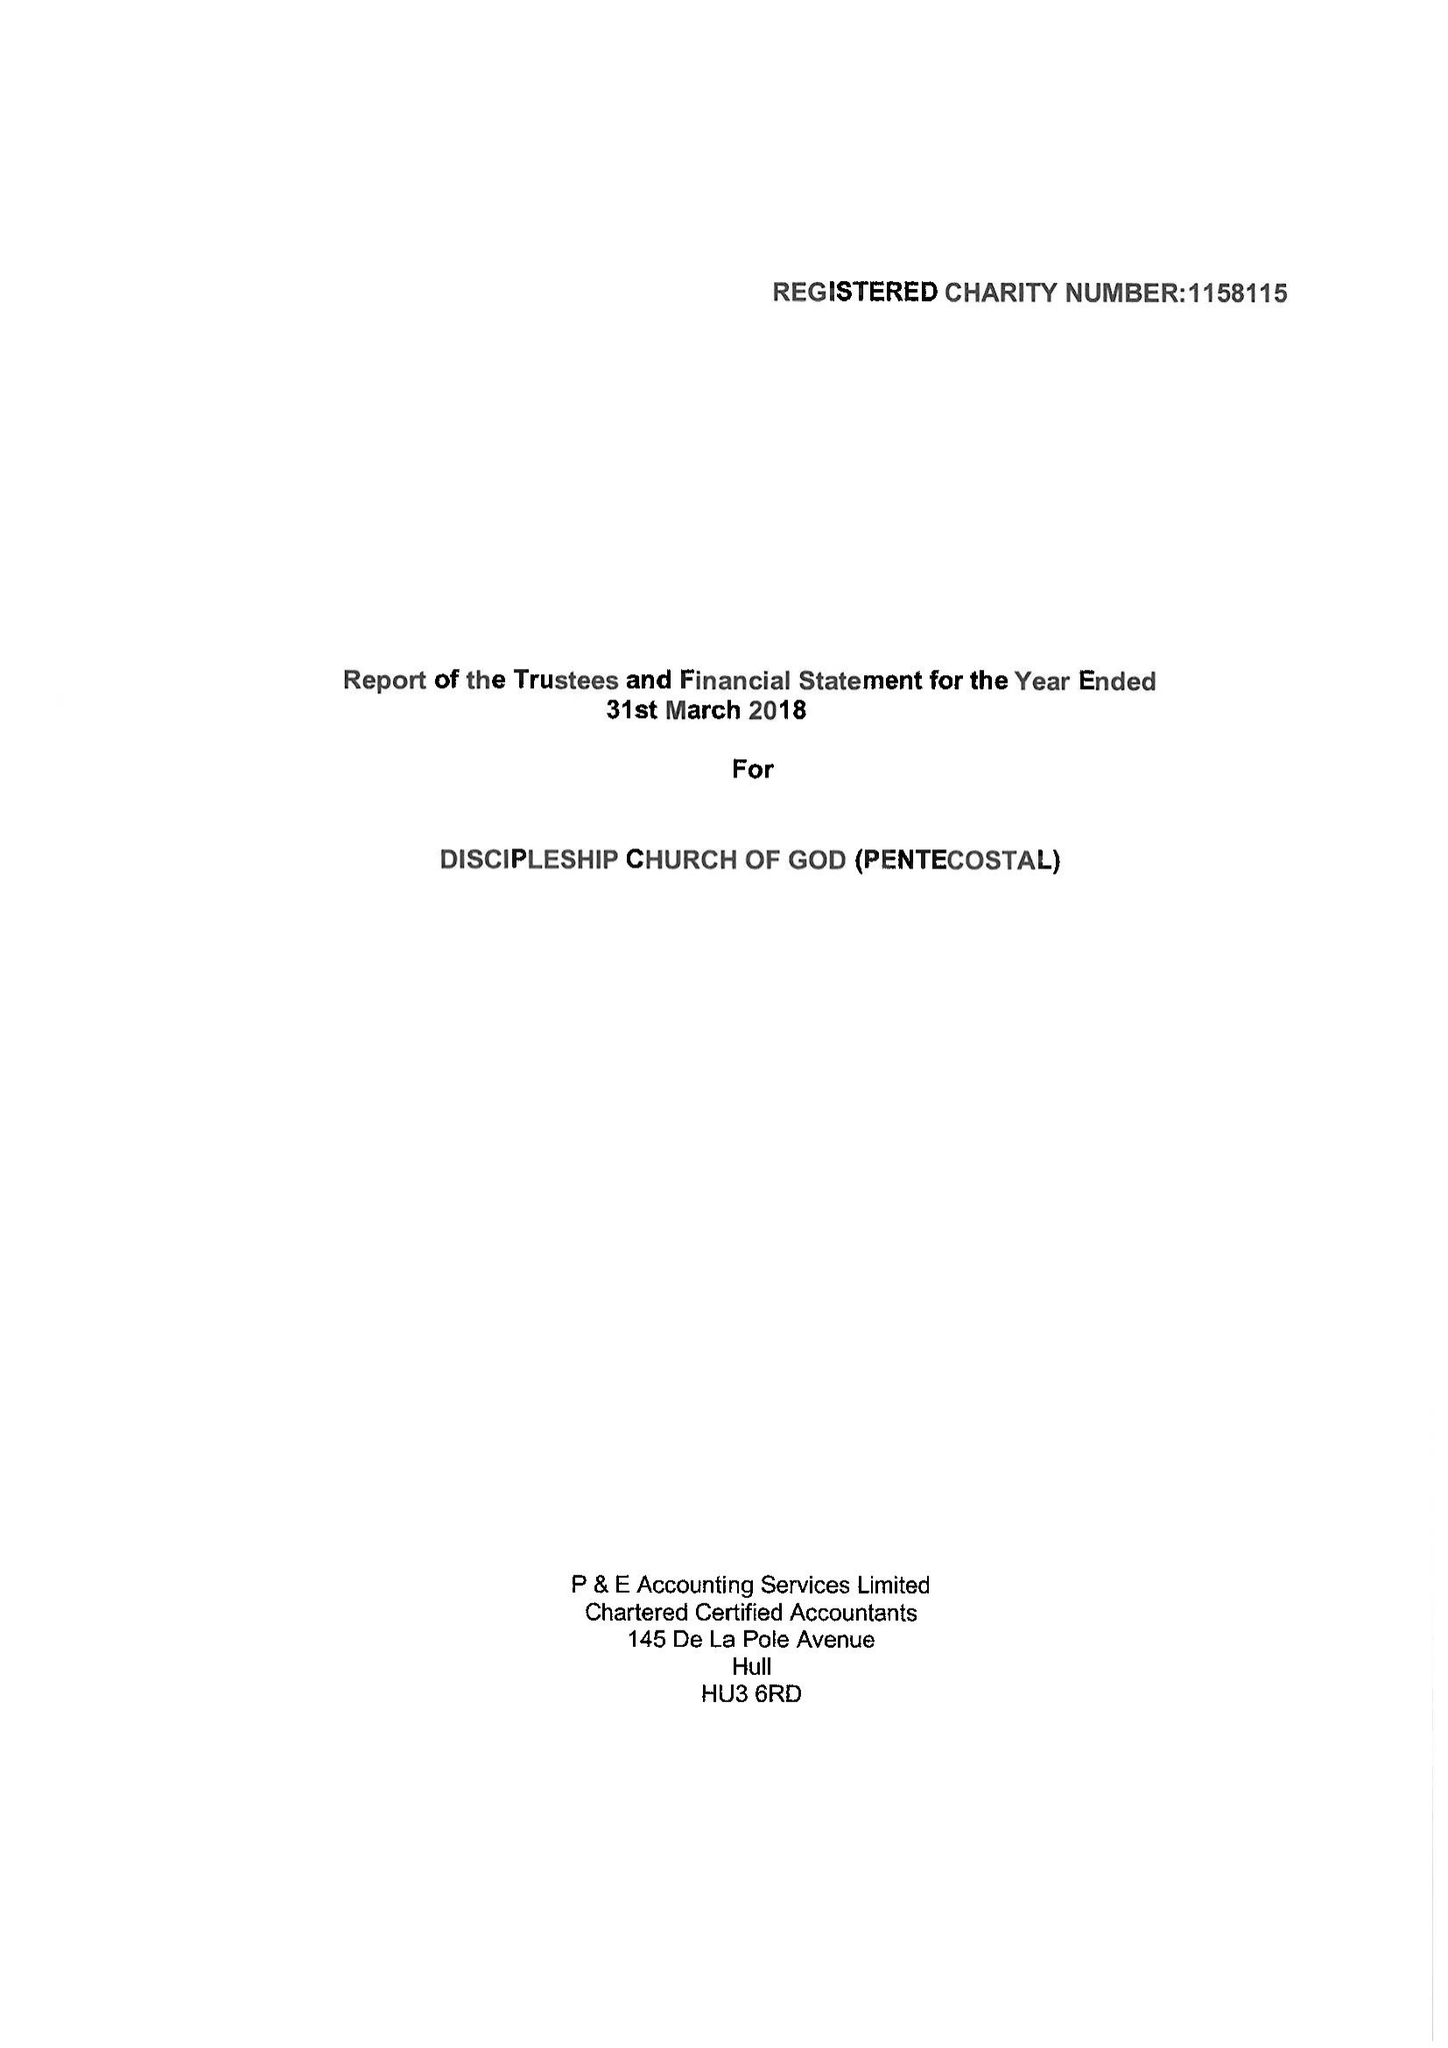What is the value for the spending_annually_in_british_pounds?
Answer the question using a single word or phrase. 7659.19 